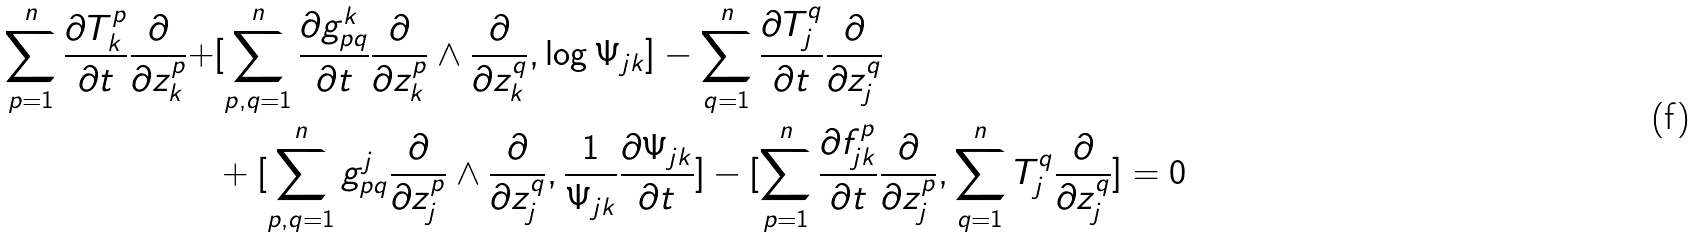<formula> <loc_0><loc_0><loc_500><loc_500>\sum _ { p = 1 } ^ { n } \frac { \partial T _ { k } ^ { p } } { \partial t } \frac { \partial } { \partial z _ { k } ^ { p } } + & [ \sum _ { p , q = 1 } ^ { n } \frac { \partial g _ { p q } ^ { k } } { \partial t } \frac { \partial } { \partial z _ { k } ^ { p } } \wedge \frac { \partial } { \partial z _ { k } ^ { q } } , \log \Psi _ { j k } ] - \sum _ { q = 1 } ^ { n } \frac { \partial T _ { j } ^ { q } } { \partial t } \frac { \partial } { \partial z _ { j } ^ { q } } \\ & + [ \sum _ { p , q = 1 } ^ { n } g _ { p q } ^ { j } \frac { \partial } { \partial z _ { j } ^ { p } } \wedge \frac { \partial } { \partial z _ { j } ^ { q } } , \frac { 1 } { \Psi _ { j k } } \frac { \partial \Psi _ { j k } } { \partial t } ] - [ \sum _ { p = 1 } ^ { n } \frac { \partial f _ { j k } ^ { p } } { \partial t } \frac { \partial } { \partial z _ { j } ^ { p } } , \sum _ { q = 1 } ^ { n } T _ { j } ^ { q } \frac { \partial } { \partial z _ { j } ^ { q } } ] = 0</formula> 